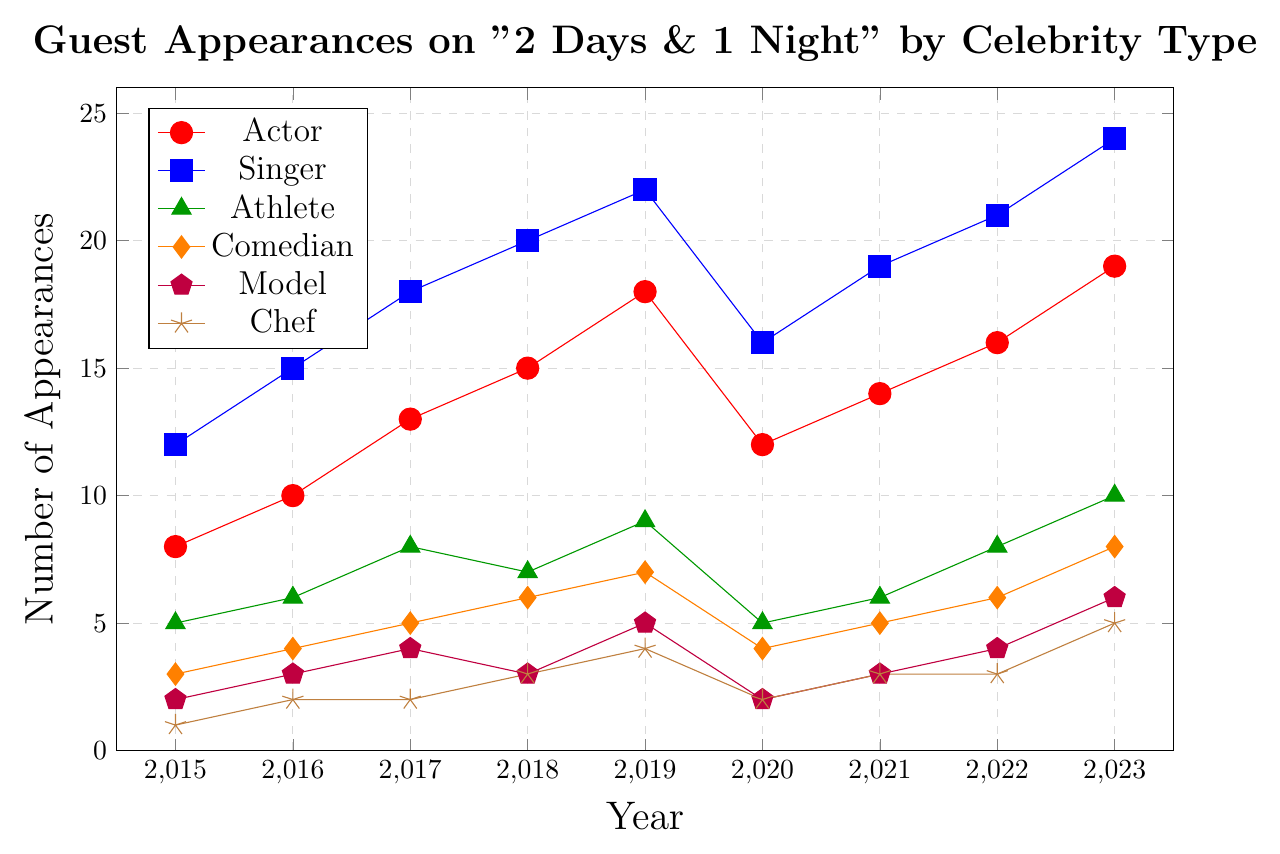Which year had the highest number of appearances by singers? Look at the plot where the blue line, representing singers, reaches its peak value vertically. The highest point is in 2023.
Answer: 2023 How many more actors appeared in 2023 compared to 2015? Find the values corresponding to actors (red line) for both years: 19 in 2023 and 8 in 2015. Subtract the 2015 value from the 2023 value: 19 - 8 = 11.
Answer: 11 How did the number of guest appearances for comedians change from 2019 to 2020? Find the value for comedians (orange line) in 2019 and 2020: 7 in 2019 and 4 in 2020. Subtract the 2020 value from the 2019 value: 7 - 4 = 3.
Answer: Decreased by 3 Which celebrity type saw the most consistent increase in appearances from 2015 to 2023? Examine the lines and note which one has a steadily increasing trend with minimal fluctuation. The blue line for singers shows a consistent increase each year.
Answer: Singer What is the total number of guest appearances by models over the years? Add the values for models (purple line) across all the years: 2 + 3 + 4 + 3 + 5 + 2 + 3 + 4 + 6 = 32.
Answer: 32 In which year did athletes see a decline in appearances compared to the previous year? Analyze the green line. Athletes declined from 8 in 2017 to 7 in 2018.
Answer: 2018 Which celebrity type had the fewest appearances in 2020, and how many were there? Look for the lowest point on the chart in 2020. The lowest value is for chefs (brown line) with 2 appearances.
Answer: Chef, 2 How did the number of guest appearances by chefs change from 2022 to 2023? Identify the values for chefs (brown line) in 2022 and 2023: 3 in 2022 and 5 in 2023. Subtract the 2022 value from the 2023 value: 5 - 3 = 2.
Answer: Increased by 2 Compare the number of appearances by athletes and comedians in 2019. Which group had more, and by how much? Find the values for athletes (green line) and comedians (orange line) in 2019: 9 and 7, respectively. Subtract the comedian value from the athlete value: 9 - 7 = 2.
Answer: Athletes, by 2 What is the difference in the total number of guest appearances by actors from 2020 to 2023? Sum the values for actors (red line) from 2020 to 2023: 12 + 14 + 16 + 19 = 61. Then do the same for singers: 16 + 19 + 21 + 24 = 80. Finally, subtract the sum of actors from the sum of singers: 80 - 61 = 19.
Answer: More by 19 